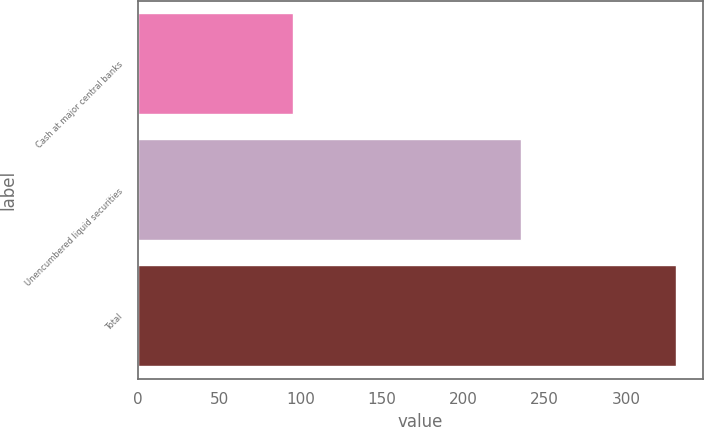<chart> <loc_0><loc_0><loc_500><loc_500><bar_chart><fcel>Cash at major central banks<fcel>Unencumbered liquid securities<fcel>Total<nl><fcel>95.2<fcel>235.6<fcel>330.8<nl></chart> 